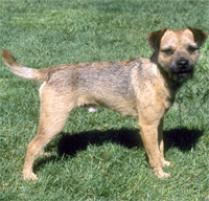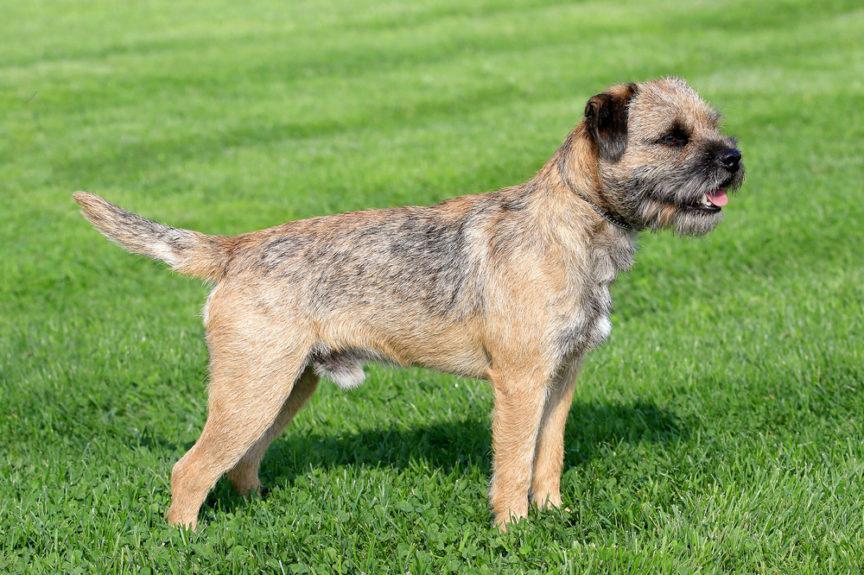The first image is the image on the left, the second image is the image on the right. Evaluate the accuracy of this statement regarding the images: "The right image contains one dog standing with its head and body in profile turned leftward, with all paws on the ground, its mouth closed, and its tail straight and extended.". Is it true? Answer yes or no. No. The first image is the image on the left, the second image is the image on the right. Evaluate the accuracy of this statement regarding the images: "The left and right image contains the same number of dogs standing in the grass.". Is it true? Answer yes or no. Yes. 